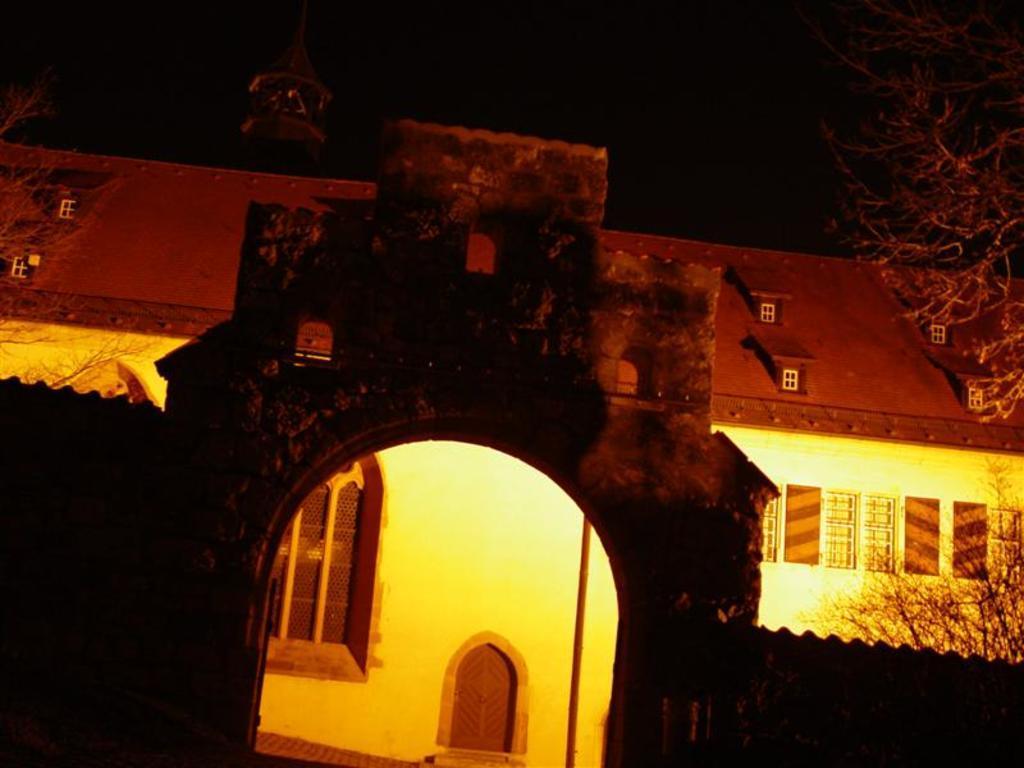What type of structure can be seen in the image? There is an arch in the image. What else is present in the image besides the arch? There are walls and a house in the image. What type of vegetation is visible in the image? There are trees in the image. How would you describe the lighting in the image? The background of the image is dark. Reasoning: Let's think step in order to produce the conversation. We start by identifying the main structures in the image, which are the arch, walls, and house. Then, we mention the presence of trees as additional elements in the image. Finally, we describe the lighting conditions by noting that the background is dark. Each question is designed to elicit a specific detail about the image that is known from the provided facts. Absurd Question/Answer: Can you see the sister swimming in the image? There is no sister or swimming activity depicted in the image. Can you see the sister kissing someone in the image? There is no sister or kissing activity depicted in the image. 